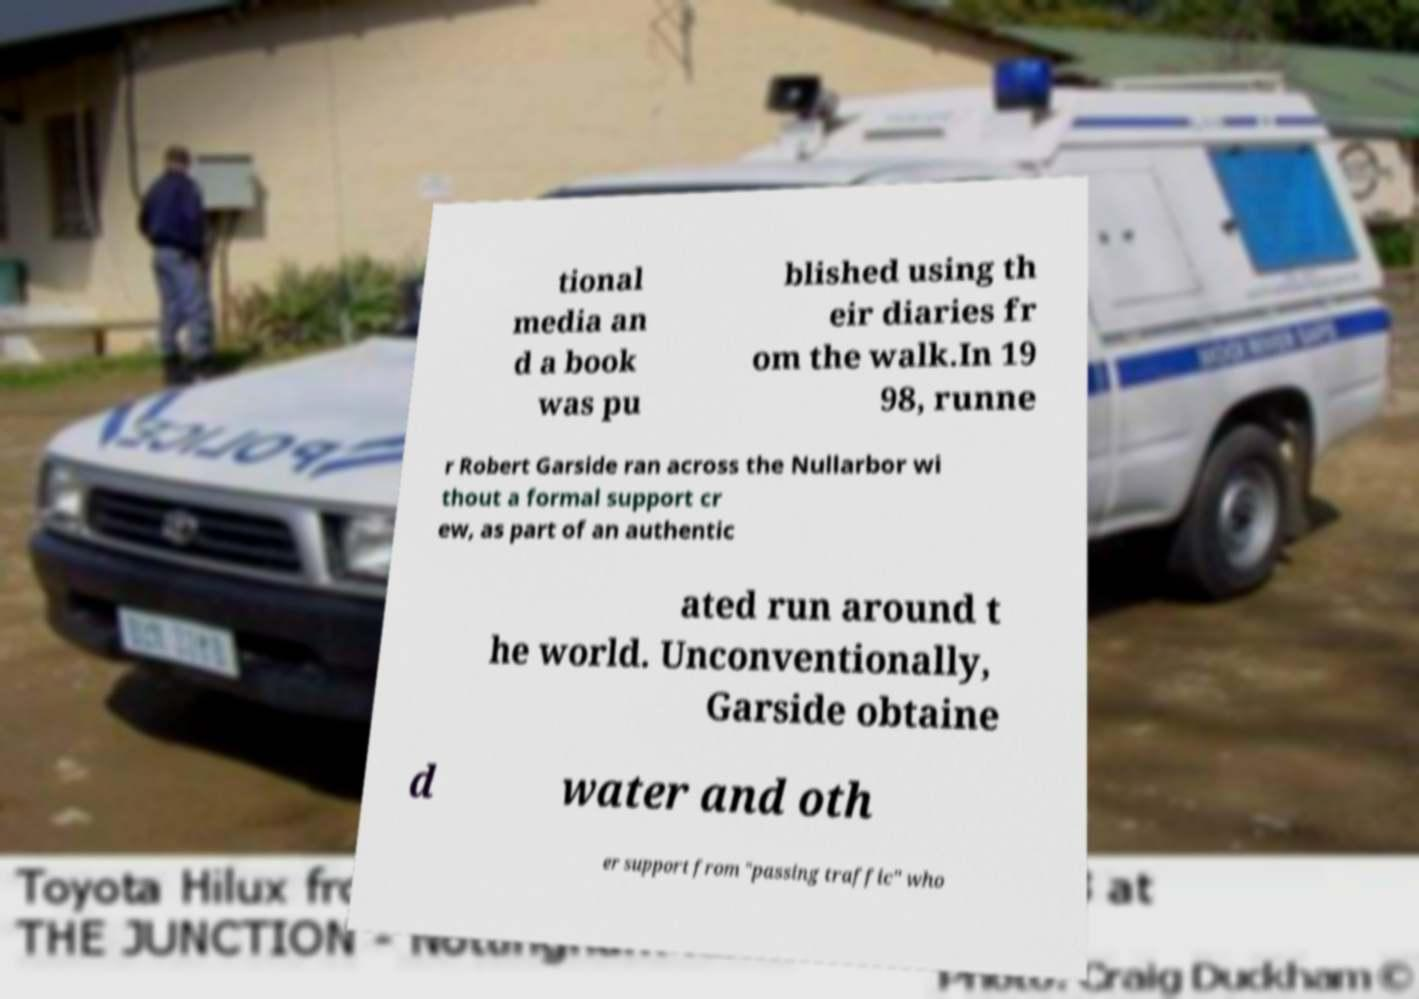Could you extract and type out the text from this image? tional media an d a book was pu blished using th eir diaries fr om the walk.In 19 98, runne r Robert Garside ran across the Nullarbor wi thout a formal support cr ew, as part of an authentic ated run around t he world. Unconventionally, Garside obtaine d water and oth er support from "passing traffic" who 